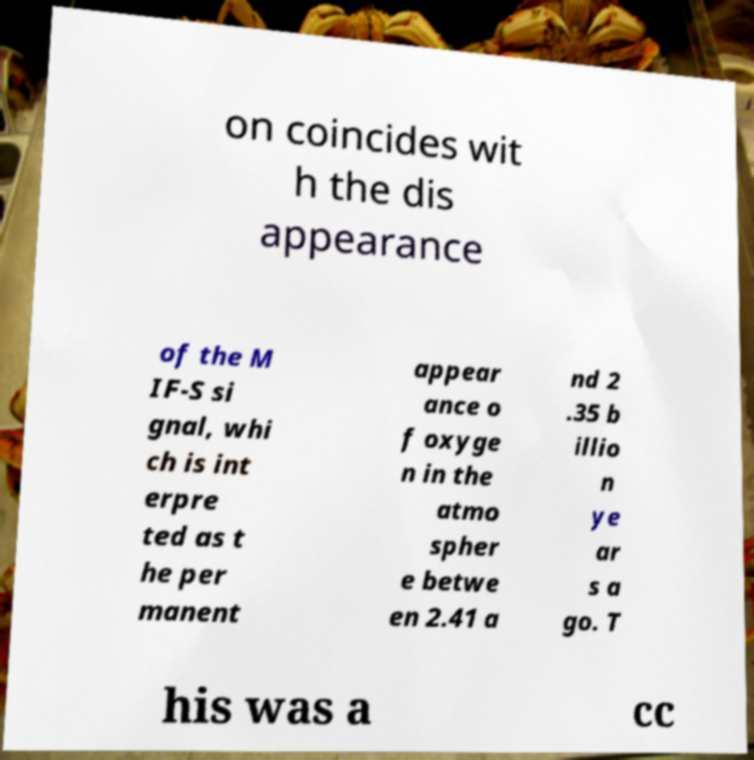For documentation purposes, I need the text within this image transcribed. Could you provide that? on coincides wit h the dis appearance of the M IF-S si gnal, whi ch is int erpre ted as t he per manent appear ance o f oxyge n in the atmo spher e betwe en 2.41 a nd 2 .35 b illio n ye ar s a go. T his was a cc 